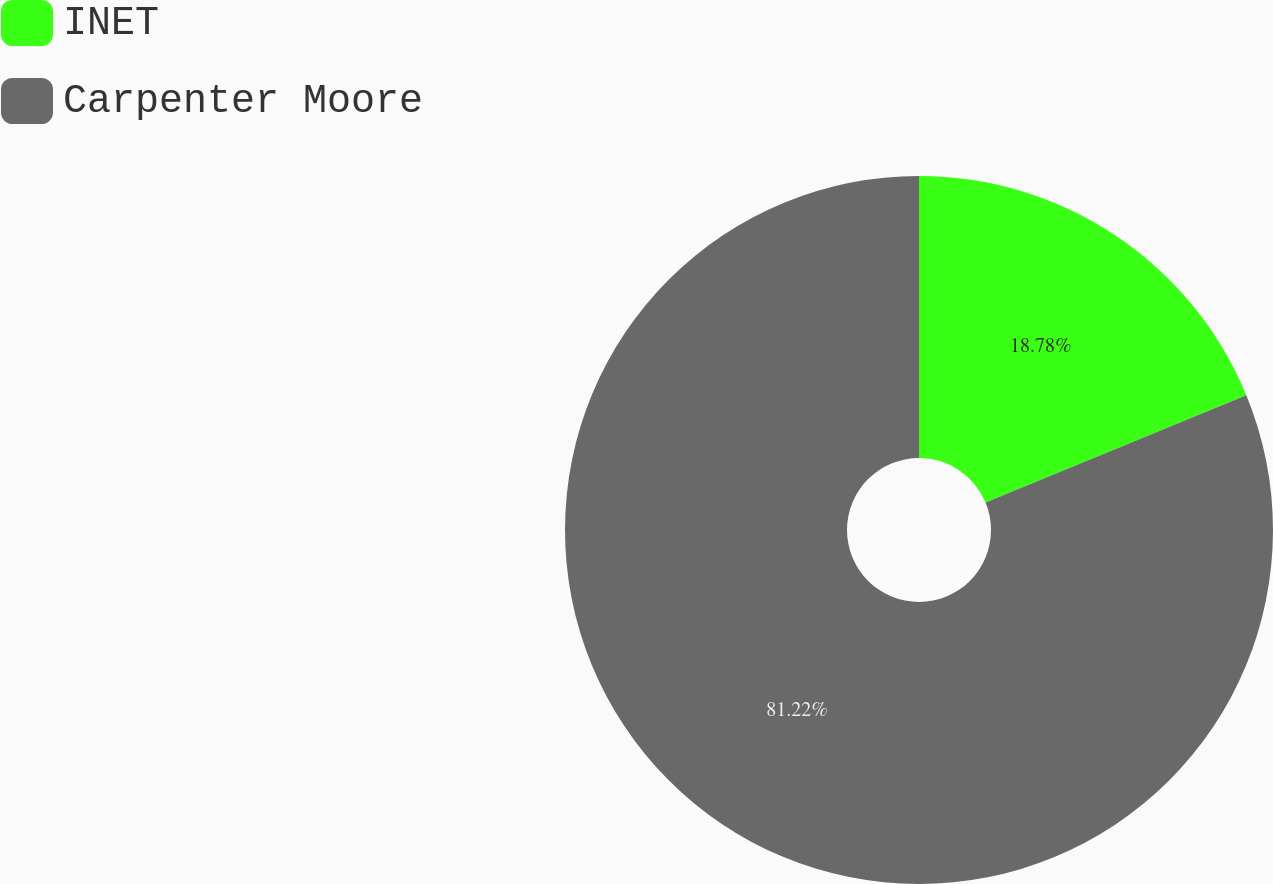<chart> <loc_0><loc_0><loc_500><loc_500><pie_chart><fcel>INET<fcel>Carpenter Moore<nl><fcel>18.78%<fcel>81.22%<nl></chart> 